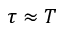<formula> <loc_0><loc_0><loc_500><loc_500>\tau \approx T</formula> 